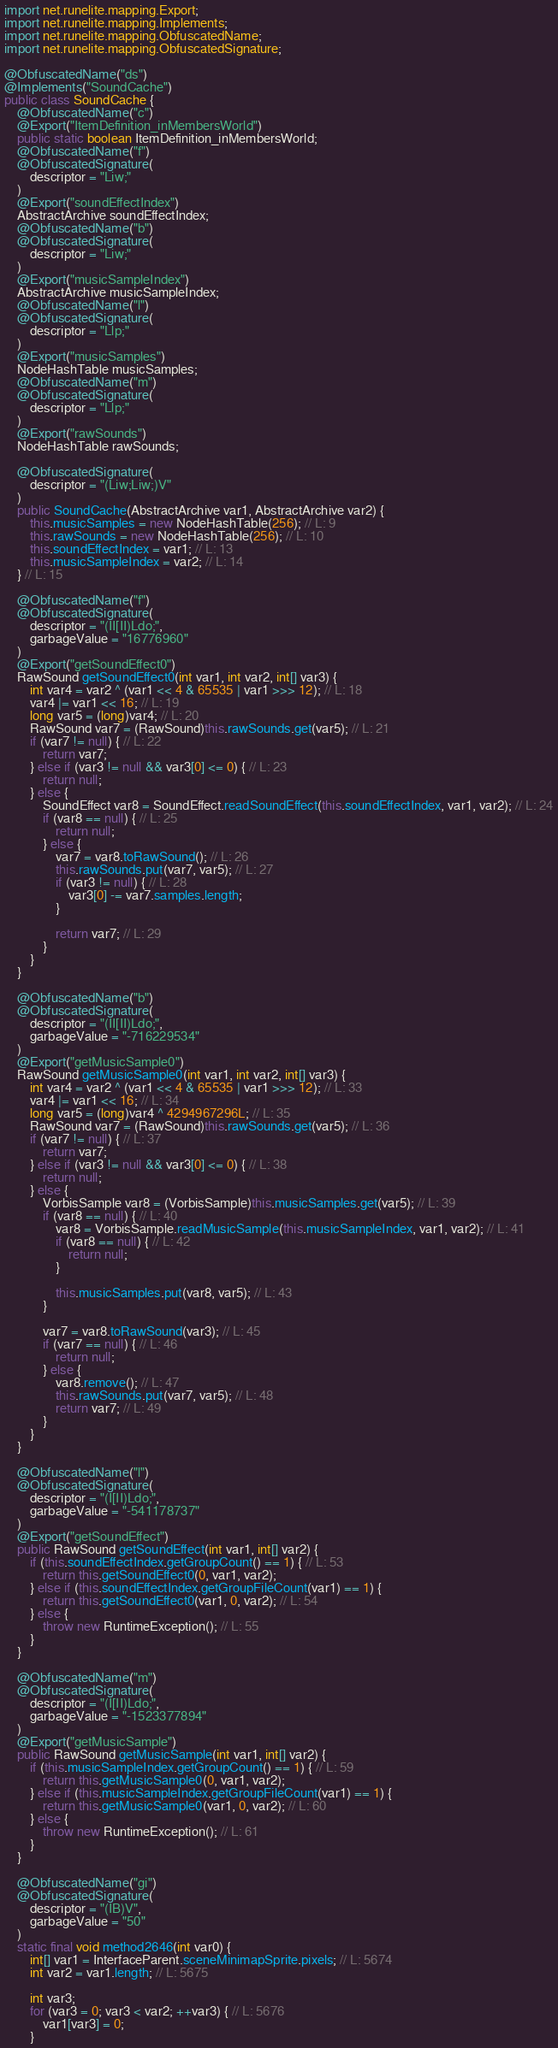<code> <loc_0><loc_0><loc_500><loc_500><_Java_>import net.runelite.mapping.Export;
import net.runelite.mapping.Implements;
import net.runelite.mapping.ObfuscatedName;
import net.runelite.mapping.ObfuscatedSignature;

@ObfuscatedName("ds")
@Implements("SoundCache")
public class SoundCache {
	@ObfuscatedName("c")
	@Export("ItemDefinition_inMembersWorld")
	public static boolean ItemDefinition_inMembersWorld;
	@ObfuscatedName("f")
	@ObfuscatedSignature(
		descriptor = "Liw;"
	)
	@Export("soundEffectIndex")
	AbstractArchive soundEffectIndex;
	@ObfuscatedName("b")
	@ObfuscatedSignature(
		descriptor = "Liw;"
	)
	@Export("musicSampleIndex")
	AbstractArchive musicSampleIndex;
	@ObfuscatedName("l")
	@ObfuscatedSignature(
		descriptor = "Llp;"
	)
	@Export("musicSamples")
	NodeHashTable musicSamples;
	@ObfuscatedName("m")
	@ObfuscatedSignature(
		descriptor = "Llp;"
	)
	@Export("rawSounds")
	NodeHashTable rawSounds;

	@ObfuscatedSignature(
		descriptor = "(Liw;Liw;)V"
	)
	public SoundCache(AbstractArchive var1, AbstractArchive var2) {
		this.musicSamples = new NodeHashTable(256); // L: 9
		this.rawSounds = new NodeHashTable(256); // L: 10
		this.soundEffectIndex = var1; // L: 13
		this.musicSampleIndex = var2; // L: 14
	} // L: 15

	@ObfuscatedName("f")
	@ObfuscatedSignature(
		descriptor = "(II[II)Ldo;",
		garbageValue = "16776960"
	)
	@Export("getSoundEffect0")
	RawSound getSoundEffect0(int var1, int var2, int[] var3) {
		int var4 = var2 ^ (var1 << 4 & 65535 | var1 >>> 12); // L: 18
		var4 |= var1 << 16; // L: 19
		long var5 = (long)var4; // L: 20
		RawSound var7 = (RawSound)this.rawSounds.get(var5); // L: 21
		if (var7 != null) { // L: 22
			return var7;
		} else if (var3 != null && var3[0] <= 0) { // L: 23
			return null;
		} else {
			SoundEffect var8 = SoundEffect.readSoundEffect(this.soundEffectIndex, var1, var2); // L: 24
			if (var8 == null) { // L: 25
				return null;
			} else {
				var7 = var8.toRawSound(); // L: 26
				this.rawSounds.put(var7, var5); // L: 27
				if (var3 != null) { // L: 28
					var3[0] -= var7.samples.length;
				}

				return var7; // L: 29
			}
		}
	}

	@ObfuscatedName("b")
	@ObfuscatedSignature(
		descriptor = "(II[II)Ldo;",
		garbageValue = "-716229534"
	)
	@Export("getMusicSample0")
	RawSound getMusicSample0(int var1, int var2, int[] var3) {
		int var4 = var2 ^ (var1 << 4 & 65535 | var1 >>> 12); // L: 33
		var4 |= var1 << 16; // L: 34
		long var5 = (long)var4 ^ 4294967296L; // L: 35
		RawSound var7 = (RawSound)this.rawSounds.get(var5); // L: 36
		if (var7 != null) { // L: 37
			return var7;
		} else if (var3 != null && var3[0] <= 0) { // L: 38
			return null;
		} else {
			VorbisSample var8 = (VorbisSample)this.musicSamples.get(var5); // L: 39
			if (var8 == null) { // L: 40
				var8 = VorbisSample.readMusicSample(this.musicSampleIndex, var1, var2); // L: 41
				if (var8 == null) { // L: 42
					return null;
				}

				this.musicSamples.put(var8, var5); // L: 43
			}

			var7 = var8.toRawSound(var3); // L: 45
			if (var7 == null) { // L: 46
				return null;
			} else {
				var8.remove(); // L: 47
				this.rawSounds.put(var7, var5); // L: 48
				return var7; // L: 49
			}
		}
	}

	@ObfuscatedName("l")
	@ObfuscatedSignature(
		descriptor = "(I[II)Ldo;",
		garbageValue = "-541178737"
	)
	@Export("getSoundEffect")
	public RawSound getSoundEffect(int var1, int[] var2) {
		if (this.soundEffectIndex.getGroupCount() == 1) { // L: 53
			return this.getSoundEffect0(0, var1, var2);
		} else if (this.soundEffectIndex.getGroupFileCount(var1) == 1) {
			return this.getSoundEffect0(var1, 0, var2); // L: 54
		} else {
			throw new RuntimeException(); // L: 55
		}
	}

	@ObfuscatedName("m")
	@ObfuscatedSignature(
		descriptor = "(I[II)Ldo;",
		garbageValue = "-1523377894"
	)
	@Export("getMusicSample")
	public RawSound getMusicSample(int var1, int[] var2) {
		if (this.musicSampleIndex.getGroupCount() == 1) { // L: 59
			return this.getMusicSample0(0, var1, var2);
		} else if (this.musicSampleIndex.getGroupFileCount(var1) == 1) {
			return this.getMusicSample0(var1, 0, var2); // L: 60
		} else {
			throw new RuntimeException(); // L: 61
		}
	}

	@ObfuscatedName("gi")
	@ObfuscatedSignature(
		descriptor = "(IB)V",
		garbageValue = "50"
	)
	static final void method2646(int var0) {
		int[] var1 = InterfaceParent.sceneMinimapSprite.pixels; // L: 5674
		int var2 = var1.length; // L: 5675

		int var3;
		for (var3 = 0; var3 < var2; ++var3) { // L: 5676
			var1[var3] = 0;
		}
</code> 